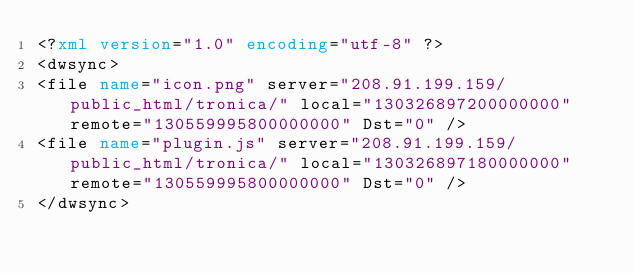Convert code to text. <code><loc_0><loc_0><loc_500><loc_500><_XML_><?xml version="1.0" encoding="utf-8" ?>
<dwsync>
<file name="icon.png" server="208.91.199.159/public_html/tronica/" local="130326897200000000" remote="130559995800000000" Dst="0" />
<file name="plugin.js" server="208.91.199.159/public_html/tronica/" local="130326897180000000" remote="130559995800000000" Dst="0" />
</dwsync></code> 